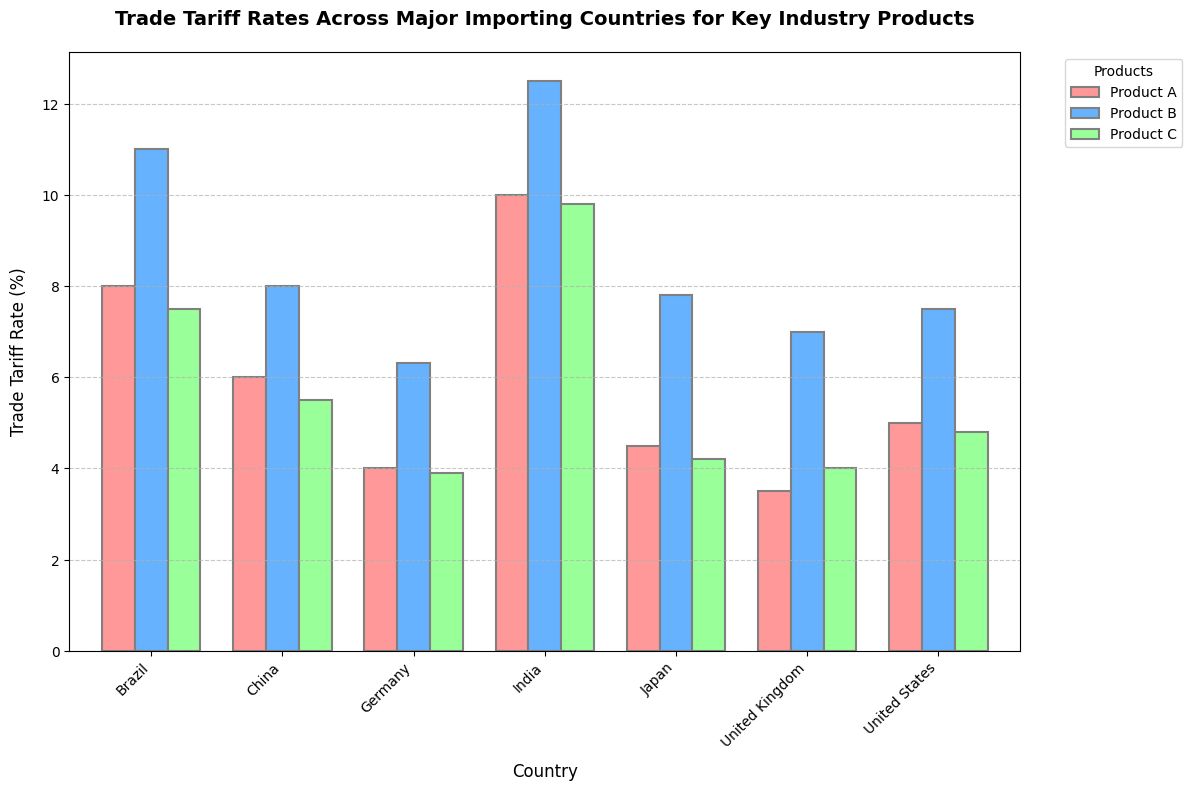What is the trade tariff rate for Product B in Germany? Locate the bar representing Germany for Product B, which should be colored in blue. The height of this bar is 6.3%.
Answer: 6.3% Which country has the highest trade tariff rate for Product A? Compare the heights of the bars for Product A across all countries. The tallest bar corresponds to India, with a rate of 10%.
Answer: India What is the difference in trade tariff rates for Product C between the United Kingdom and India? Locate the bars representing the United Kingdom and India for Product C. The rates are 4% and 9.8%, respectively. Subtract 4% from 9.8% to get the difference.
Answer: 5.8% Which product has the lowest trade tariff rate in Brazil? Compare the bars representing Product A, Product B, and Product C in Brazil. The bar for Product C is the shortest, indicating a rate of 7.5%.
Answer: Product C What is the average trade tariff rate for Product B across all countries? Sum the tariff rates for Product B across the United States (7.5%), China (8%), Germany (6.3%), United Kingdom (7%), Japan (7.8%), India (12.5%), and Brazil (11%). The total is 60.1%. Divide by 7 (number of countries) to get the average.
Answer: 8.6% Which country has the smallest trade tariff rate for any product, and what is the rate? Identify the smallest bar across all products and countries. The shortest bar is for Product A in the United Kingdom with a rate of 3.5%.
Answer: United Kingdom, 3.5% Is the trade tariff rate for Product A higher in China or Japan? Compare the height of the bars for Product A in China (6%) and Japan (4.5%). The bar for China is taller.
Answer: China What is the total trade tariff rate for all products in the United States? Sum the trade tariff rates for Product A (5%), Product B (7.5%), and Product C (4.8%) in the United States. The total is 5% + 7.5% + 4.8%, which equals 17.3%.
Answer: 17.3% Which country has the greatest variation in trade tariff rates among all products? Calculate the range for each country's products by subtracting the smallest rate from the highest rate. The country with the largest range has the greatest variation. Check each country: 
United States (7.5% - 4.8% = 2.7%), 
China (8% - 5.5% = 2.5%), 
Germany (6.3% - 3.9% = 2.4%), 
United Kingdom (7% - 3.5% = 3.5%), 
Japan (7.8% - 4.2% = 3.6%), 
India (12.5% - 9.8% = 2.7%), 
Brazil (11% - 7.5% = 3.5%). Japan and the United Kingdom both have the greatest variation with a range of 3.5%.
Answer: Japan and United Kingdom 